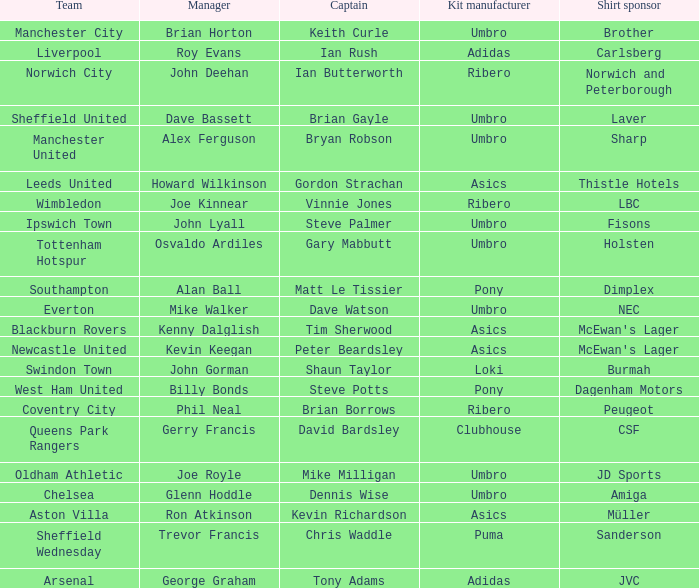Which manager has sheffield wednesday as the team? Trevor Francis. Would you mind parsing the complete table? {'header': ['Team', 'Manager', 'Captain', 'Kit manufacturer', 'Shirt sponsor'], 'rows': [['Manchester City', 'Brian Horton', 'Keith Curle', 'Umbro', 'Brother'], ['Liverpool', 'Roy Evans', 'Ian Rush', 'Adidas', 'Carlsberg'], ['Norwich City', 'John Deehan', 'Ian Butterworth', 'Ribero', 'Norwich and Peterborough'], ['Sheffield United', 'Dave Bassett', 'Brian Gayle', 'Umbro', 'Laver'], ['Manchester United', 'Alex Ferguson', 'Bryan Robson', 'Umbro', 'Sharp'], ['Leeds United', 'Howard Wilkinson', 'Gordon Strachan', 'Asics', 'Thistle Hotels'], ['Wimbledon', 'Joe Kinnear', 'Vinnie Jones', 'Ribero', 'LBC'], ['Ipswich Town', 'John Lyall', 'Steve Palmer', 'Umbro', 'Fisons'], ['Tottenham Hotspur', 'Osvaldo Ardiles', 'Gary Mabbutt', 'Umbro', 'Holsten'], ['Southampton', 'Alan Ball', 'Matt Le Tissier', 'Pony', 'Dimplex'], ['Everton', 'Mike Walker', 'Dave Watson', 'Umbro', 'NEC'], ['Blackburn Rovers', 'Kenny Dalglish', 'Tim Sherwood', 'Asics', "McEwan's Lager"], ['Newcastle United', 'Kevin Keegan', 'Peter Beardsley', 'Asics', "McEwan's Lager"], ['Swindon Town', 'John Gorman', 'Shaun Taylor', 'Loki', 'Burmah'], ['West Ham United', 'Billy Bonds', 'Steve Potts', 'Pony', 'Dagenham Motors'], ['Coventry City', 'Phil Neal', 'Brian Borrows', 'Ribero', 'Peugeot'], ['Queens Park Rangers', 'Gerry Francis', 'David Bardsley', 'Clubhouse', 'CSF'], ['Oldham Athletic', 'Joe Royle', 'Mike Milligan', 'Umbro', 'JD Sports'], ['Chelsea', 'Glenn Hoddle', 'Dennis Wise', 'Umbro', 'Amiga'], ['Aston Villa', 'Ron Atkinson', 'Kevin Richardson', 'Asics', 'Müller'], ['Sheffield Wednesday', 'Trevor Francis', 'Chris Waddle', 'Puma', 'Sanderson'], ['Arsenal', 'George Graham', 'Tony Adams', 'Adidas', 'JVC']]} 